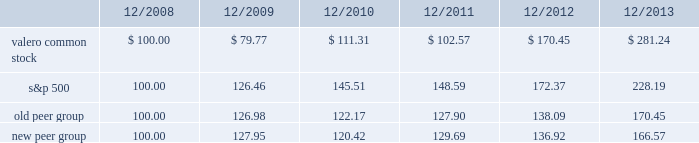Table of contents the following performance graph is not 201csoliciting material , 201d is not deemed filed with the sec , and is not to be incorporated by reference into any of valero 2019s filings under the securities act of 1933 or the securities exchange act of 1934 , as amended , respectively .
This performance graph and the related textual information are based on historical data and are not indicative of future performance .
The following line graph compares the cumulative total return 1 on an investment in our common stock against the cumulative total return of the s&p 500 composite index and an index of peer companies ( that we selected ) for the five-year period commencing december 31 , 2008 and ending december 31 , 2013 .
Our peer group comprises the following 11 companies : alon usa energy , inc. ; bp plc ; cvr energy , inc. ; delek us holdings , inc .
( dk ) ; hollyfrontier corporation ; marathon petroleum corporation ; pbf energy inc .
( pbf ) ; phillips 66 ; royal dutch shell plc ; tesoro corporation ; and western refining , inc .
Our peer group previously included hess corporation , but it has exited the refining business , and was replaced in our peer group by dk and pbf who are also engaged in refining operations .
Comparison of 5 year cumulative total return1 among valero energy corporation , the s&p 500 index , old peer group , and new peer group .
____________ 1 assumes that an investment in valero common stock and each index was $ 100 on december 31 , 2008 .
201ccumulative total return 201d is based on share price appreciation plus reinvestment of dividends from december 31 , 2008 through december 31 , 2013. .
What was the percentage growth of the valero common stock from 2009 to 2011? 
Computations: ((111.31 - 79.77) / 79.77)
Answer: 0.39539. 